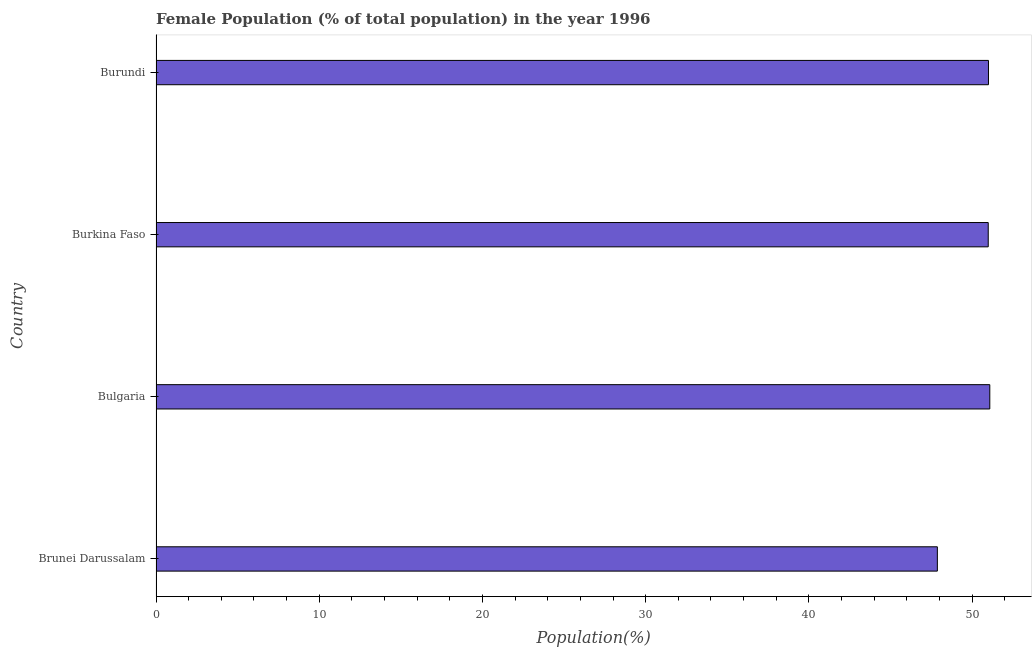What is the title of the graph?
Offer a terse response. Female Population (% of total population) in the year 1996. What is the label or title of the X-axis?
Give a very brief answer. Population(%). What is the female population in Bulgaria?
Make the answer very short. 51.09. Across all countries, what is the maximum female population?
Your answer should be compact. 51.09. Across all countries, what is the minimum female population?
Your response must be concise. 47.87. In which country was the female population maximum?
Provide a succinct answer. Bulgaria. In which country was the female population minimum?
Your answer should be compact. Brunei Darussalam. What is the sum of the female population?
Provide a short and direct response. 200.95. What is the difference between the female population in Bulgaria and Burkina Faso?
Provide a short and direct response. 0.1. What is the average female population per country?
Make the answer very short. 50.24. What is the median female population?
Give a very brief answer. 51. What is the ratio of the female population in Bulgaria to that in Burundi?
Provide a succinct answer. 1. Is the difference between the female population in Bulgaria and Burkina Faso greater than the difference between any two countries?
Keep it short and to the point. No. What is the difference between the highest and the second highest female population?
Give a very brief answer. 0.08. What is the difference between the highest and the lowest female population?
Ensure brevity in your answer.  3.21. In how many countries, is the female population greater than the average female population taken over all countries?
Your answer should be compact. 3. How many bars are there?
Provide a succinct answer. 4. Are all the bars in the graph horizontal?
Give a very brief answer. Yes. How many countries are there in the graph?
Your answer should be compact. 4. What is the difference between two consecutive major ticks on the X-axis?
Ensure brevity in your answer.  10. Are the values on the major ticks of X-axis written in scientific E-notation?
Keep it short and to the point. No. What is the Population(%) of Brunei Darussalam?
Provide a succinct answer. 47.87. What is the Population(%) in Bulgaria?
Provide a succinct answer. 51.09. What is the Population(%) of Burkina Faso?
Keep it short and to the point. 50.99. What is the Population(%) in Burundi?
Provide a succinct answer. 51. What is the difference between the Population(%) in Brunei Darussalam and Bulgaria?
Make the answer very short. -3.21. What is the difference between the Population(%) in Brunei Darussalam and Burkina Faso?
Give a very brief answer. -3.12. What is the difference between the Population(%) in Brunei Darussalam and Burundi?
Keep it short and to the point. -3.13. What is the difference between the Population(%) in Bulgaria and Burkina Faso?
Your answer should be compact. 0.1. What is the difference between the Population(%) in Bulgaria and Burundi?
Keep it short and to the point. 0.08. What is the difference between the Population(%) in Burkina Faso and Burundi?
Give a very brief answer. -0.01. What is the ratio of the Population(%) in Brunei Darussalam to that in Bulgaria?
Make the answer very short. 0.94. What is the ratio of the Population(%) in Brunei Darussalam to that in Burkina Faso?
Provide a succinct answer. 0.94. What is the ratio of the Population(%) in Brunei Darussalam to that in Burundi?
Your response must be concise. 0.94. What is the ratio of the Population(%) in Bulgaria to that in Burundi?
Provide a succinct answer. 1. 